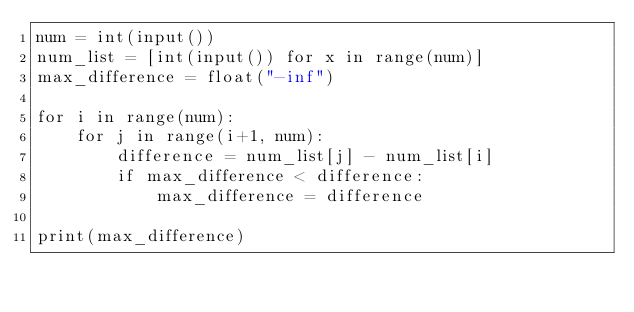Convert code to text. <code><loc_0><loc_0><loc_500><loc_500><_Python_>num = int(input())
num_list = [int(input()) for x in range(num)]
max_difference = float("-inf")

for i in range(num):
    for j in range(i+1, num):
        difference = num_list[j] - num_list[i]
        if max_difference < difference:
            max_difference = difference

print(max_difference)</code> 